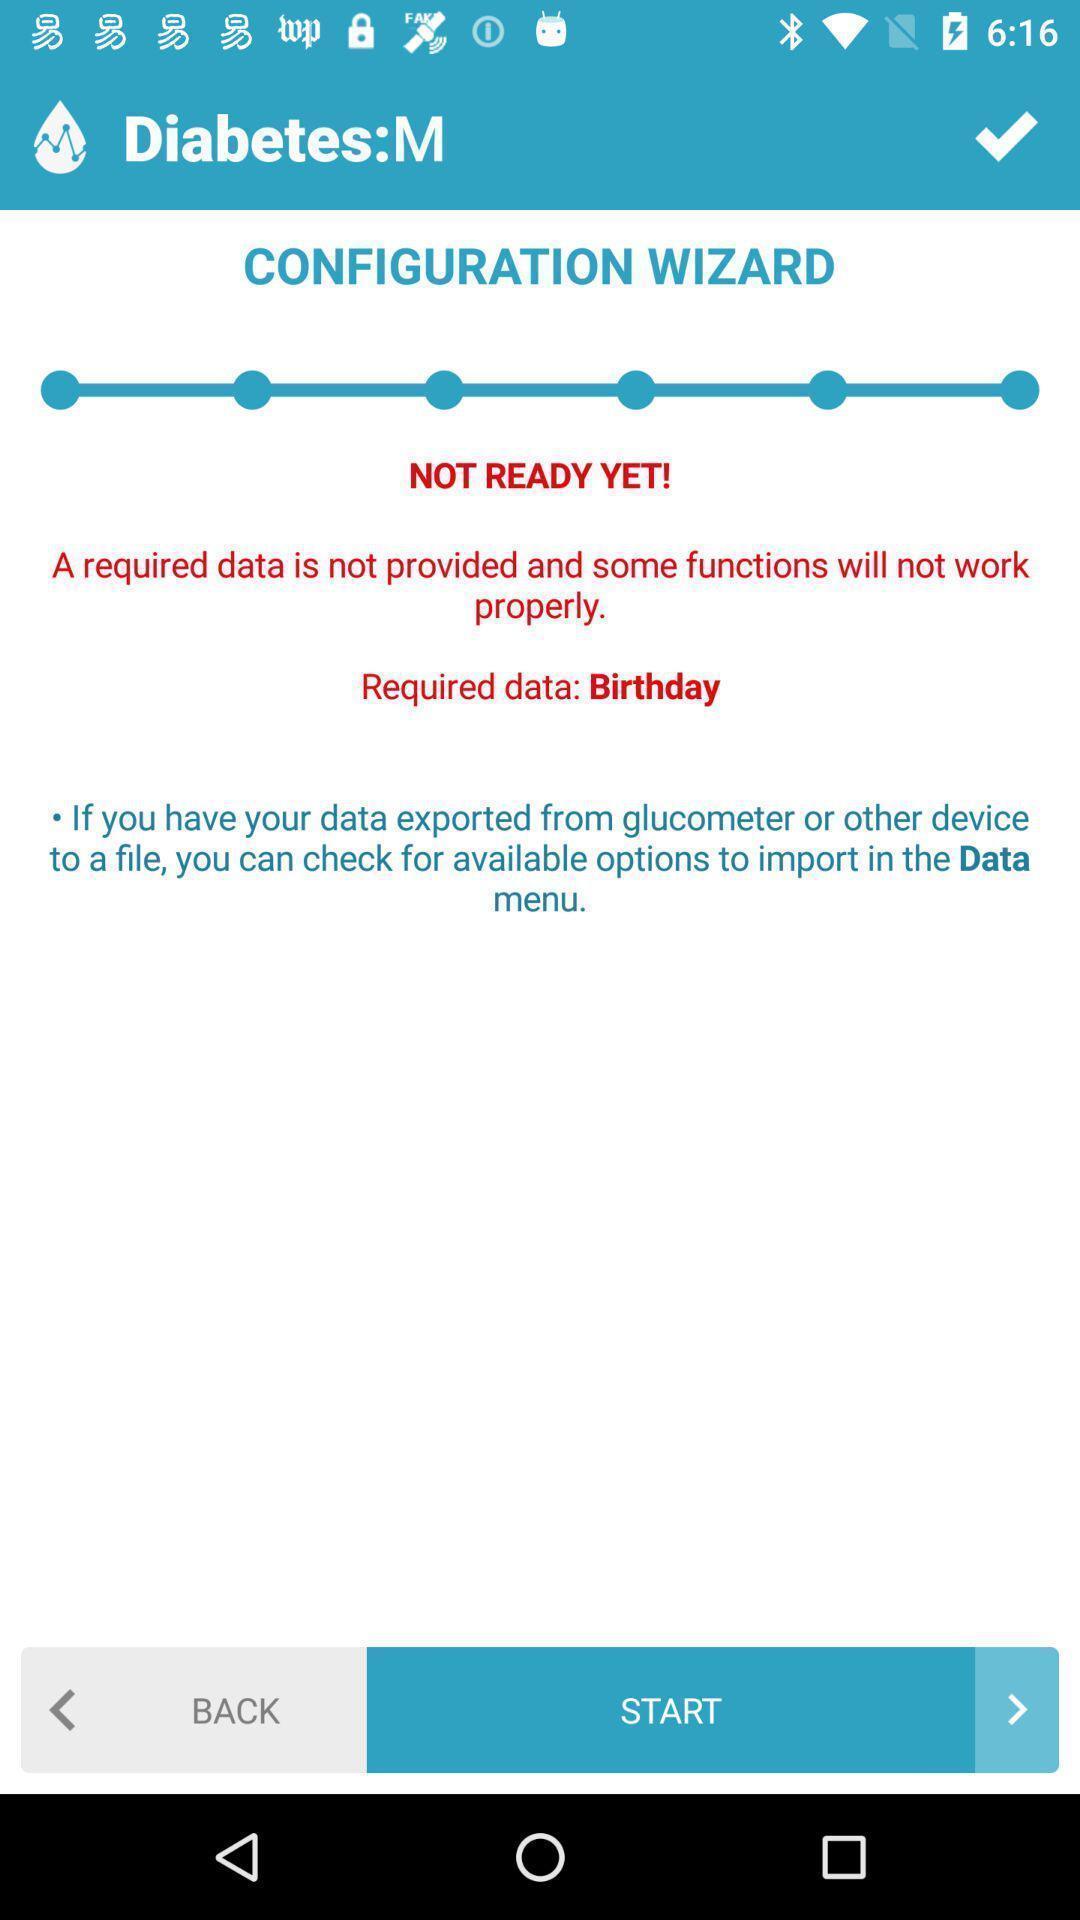What can you discern from this picture? Welcome page displayed to start. 